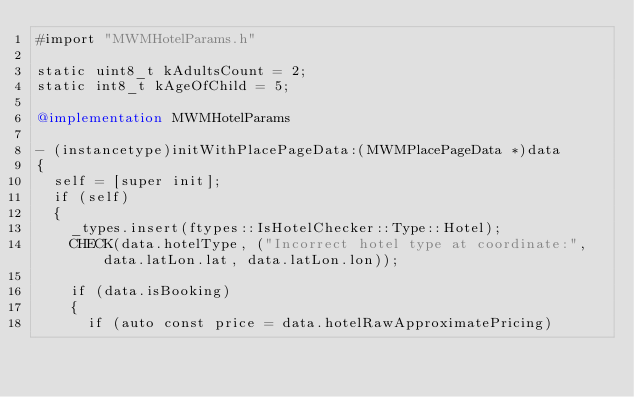Convert code to text. <code><loc_0><loc_0><loc_500><loc_500><_ObjectiveC_>#import "MWMHotelParams.h"

static uint8_t kAdultsCount = 2;
static int8_t kAgeOfChild = 5;

@implementation MWMHotelParams

- (instancetype)initWithPlacePageData:(MWMPlacePageData *)data
{
  self = [super init];
  if (self)
  {
    _types.insert(ftypes::IsHotelChecker::Type::Hotel);
    CHECK(data.hotelType, ("Incorrect hotel type at coordinate:", data.latLon.lat, data.latLon.lon));
    
    if (data.isBooking)
    {
      if (auto const price = data.hotelRawApproximatePricing)</code> 